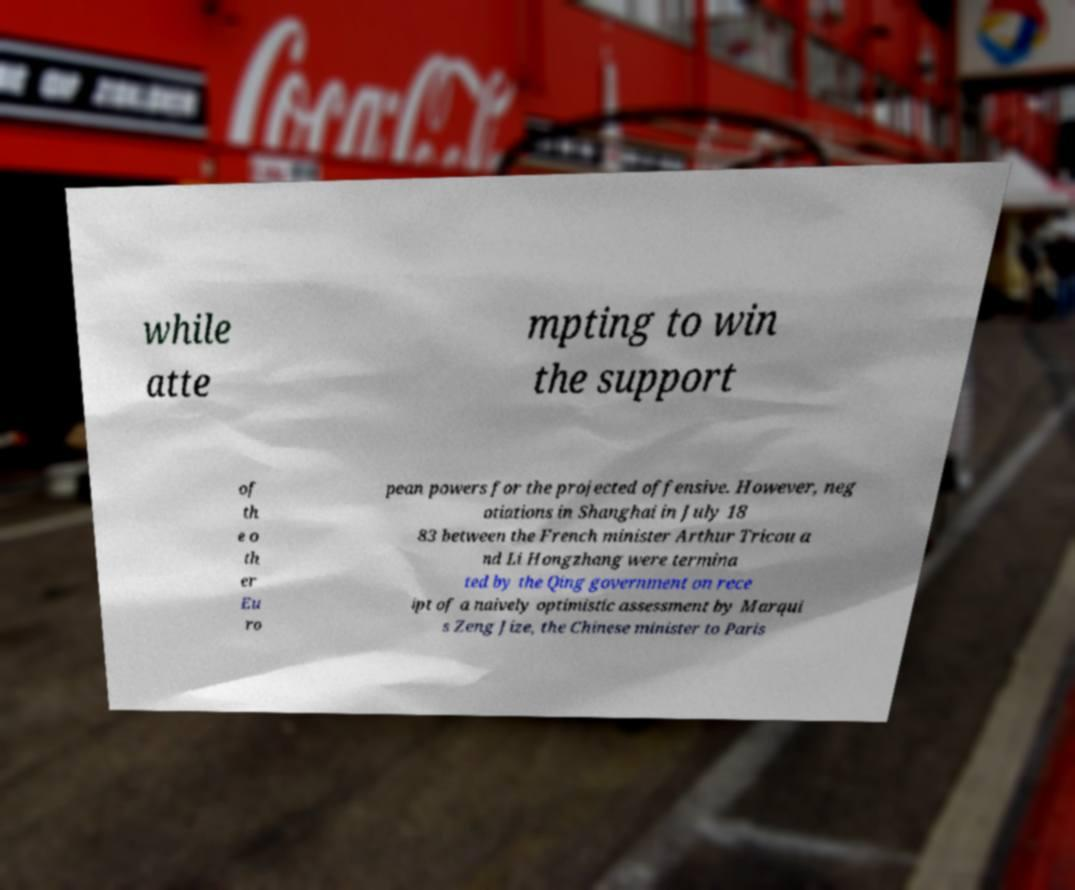What messages or text are displayed in this image? I need them in a readable, typed format. while atte mpting to win the support of th e o th er Eu ro pean powers for the projected offensive. However, neg otiations in Shanghai in July 18 83 between the French minister Arthur Tricou a nd Li Hongzhang were termina ted by the Qing government on rece ipt of a naively optimistic assessment by Marqui s Zeng Jize, the Chinese minister to Paris 